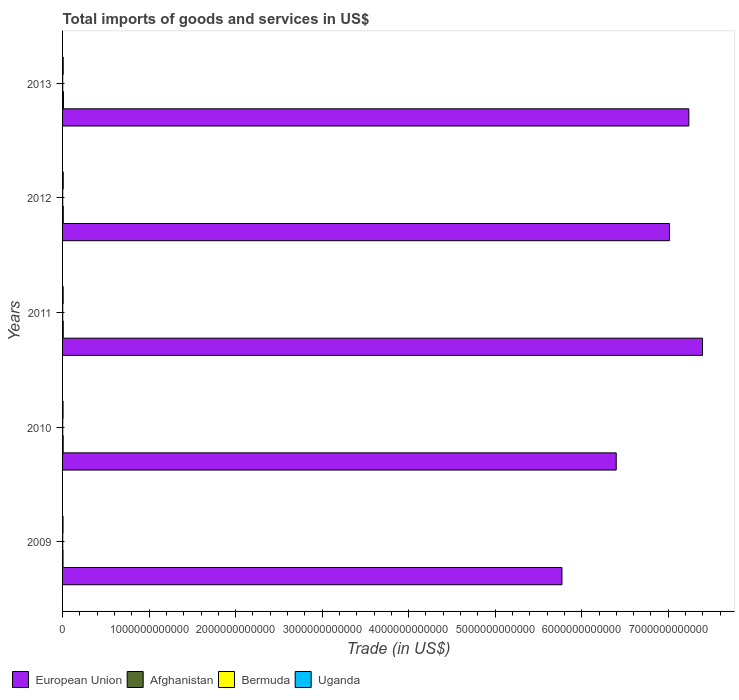How many different coloured bars are there?
Your answer should be very brief. 4. How many groups of bars are there?
Your answer should be very brief. 5. Are the number of bars per tick equal to the number of legend labels?
Offer a very short reply. Yes. Are the number of bars on each tick of the Y-axis equal?
Offer a terse response. Yes. How many bars are there on the 4th tick from the bottom?
Provide a succinct answer. 4. What is the label of the 3rd group of bars from the top?
Provide a short and direct response. 2011. In how many cases, is the number of bars for a given year not equal to the number of legend labels?
Give a very brief answer. 0. What is the total imports of goods and services in European Union in 2010?
Keep it short and to the point. 6.40e+12. Across all years, what is the maximum total imports of goods and services in European Union?
Your answer should be compact. 7.40e+12. Across all years, what is the minimum total imports of goods and services in Uganda?
Provide a succinct answer. 5.34e+09. In which year was the total imports of goods and services in Afghanistan minimum?
Keep it short and to the point. 2009. What is the total total imports of goods and services in Uganda in the graph?
Your answer should be compact. 3.31e+1. What is the difference between the total imports of goods and services in European Union in 2009 and that in 2013?
Your answer should be very brief. -1.47e+12. What is the difference between the total imports of goods and services in Bermuda in 2009 and the total imports of goods and services in Uganda in 2012?
Make the answer very short. -5.89e+09. What is the average total imports of goods and services in Uganda per year?
Offer a terse response. 6.63e+09. In the year 2012, what is the difference between the total imports of goods and services in Bermuda and total imports of goods and services in Uganda?
Keep it short and to the point. -6.07e+09. What is the ratio of the total imports of goods and services in Uganda in 2010 to that in 2011?
Provide a succinct answer. 0.84. Is the total imports of goods and services in European Union in 2010 less than that in 2012?
Provide a succinct answer. Yes. Is the difference between the total imports of goods and services in Bermuda in 2009 and 2011 greater than the difference between the total imports of goods and services in Uganda in 2009 and 2011?
Ensure brevity in your answer.  Yes. What is the difference between the highest and the second highest total imports of goods and services in Bermuda?
Give a very brief answer. 3.76e+07. What is the difference between the highest and the lowest total imports of goods and services in Uganda?
Your answer should be compact. 2.32e+09. In how many years, is the total imports of goods and services in Afghanistan greater than the average total imports of goods and services in Afghanistan taken over all years?
Provide a short and direct response. 3. What does the 1st bar from the top in 2010 represents?
Ensure brevity in your answer.  Uganda. What does the 2nd bar from the bottom in 2011 represents?
Offer a terse response. Afghanistan. Is it the case that in every year, the sum of the total imports of goods and services in Afghanistan and total imports of goods and services in European Union is greater than the total imports of goods and services in Bermuda?
Provide a short and direct response. Yes. How many years are there in the graph?
Provide a succinct answer. 5. What is the difference between two consecutive major ticks on the X-axis?
Provide a short and direct response. 1.00e+12. Are the values on the major ticks of X-axis written in scientific E-notation?
Keep it short and to the point. No. Does the graph contain any zero values?
Provide a short and direct response. No. Does the graph contain grids?
Your response must be concise. No. Where does the legend appear in the graph?
Your answer should be compact. Bottom left. How are the legend labels stacked?
Your response must be concise. Horizontal. What is the title of the graph?
Offer a very short reply. Total imports of goods and services in US$. What is the label or title of the X-axis?
Offer a very short reply. Trade (in US$). What is the label or title of the Y-axis?
Your response must be concise. Years. What is the Trade (in US$) in European Union in 2009?
Your response must be concise. 5.77e+12. What is the Trade (in US$) of Afghanistan in 2009?
Offer a terse response. 5.27e+09. What is the Trade (in US$) of Bermuda in 2009?
Your answer should be compact. 1.77e+09. What is the Trade (in US$) in Uganda in 2009?
Give a very brief answer. 5.34e+09. What is the Trade (in US$) in European Union in 2010?
Ensure brevity in your answer.  6.40e+12. What is the Trade (in US$) in Afghanistan in 2010?
Your response must be concise. 7.16e+09. What is the Trade (in US$) in Bermuda in 2010?
Your answer should be compact. 1.73e+09. What is the Trade (in US$) in Uganda in 2010?
Offer a terse response. 5.77e+09. What is the Trade (in US$) of European Union in 2011?
Keep it short and to the point. 7.40e+12. What is the Trade (in US$) of Afghanistan in 2011?
Keep it short and to the point. 7.92e+09. What is the Trade (in US$) of Bermuda in 2011?
Your response must be concise. 1.60e+09. What is the Trade (in US$) of Uganda in 2011?
Offer a terse response. 6.84e+09. What is the Trade (in US$) of European Union in 2012?
Keep it short and to the point. 7.01e+12. What is the Trade (in US$) of Afghanistan in 2012?
Provide a short and direct response. 8.04e+09. What is the Trade (in US$) of Bermuda in 2012?
Ensure brevity in your answer.  1.59e+09. What is the Trade (in US$) in Uganda in 2012?
Offer a very short reply. 7.66e+09. What is the Trade (in US$) in European Union in 2013?
Provide a succinct answer. 7.24e+12. What is the Trade (in US$) of Afghanistan in 2013?
Your response must be concise. 1.02e+1. What is the Trade (in US$) of Bermuda in 2013?
Your answer should be compact. 1.65e+09. What is the Trade (in US$) in Uganda in 2013?
Give a very brief answer. 7.53e+09. Across all years, what is the maximum Trade (in US$) in European Union?
Your response must be concise. 7.40e+12. Across all years, what is the maximum Trade (in US$) in Afghanistan?
Give a very brief answer. 1.02e+1. Across all years, what is the maximum Trade (in US$) in Bermuda?
Make the answer very short. 1.77e+09. Across all years, what is the maximum Trade (in US$) in Uganda?
Keep it short and to the point. 7.66e+09. Across all years, what is the minimum Trade (in US$) of European Union?
Offer a very short reply. 5.77e+12. Across all years, what is the minimum Trade (in US$) of Afghanistan?
Keep it short and to the point. 5.27e+09. Across all years, what is the minimum Trade (in US$) in Bermuda?
Give a very brief answer. 1.59e+09. Across all years, what is the minimum Trade (in US$) in Uganda?
Provide a short and direct response. 5.34e+09. What is the total Trade (in US$) of European Union in the graph?
Your response must be concise. 3.38e+13. What is the total Trade (in US$) in Afghanistan in the graph?
Ensure brevity in your answer.  3.86e+1. What is the total Trade (in US$) in Bermuda in the graph?
Your answer should be compact. 8.34e+09. What is the total Trade (in US$) of Uganda in the graph?
Offer a terse response. 3.31e+1. What is the difference between the Trade (in US$) of European Union in 2009 and that in 2010?
Provide a succinct answer. -6.27e+11. What is the difference between the Trade (in US$) of Afghanistan in 2009 and that in 2010?
Your answer should be very brief. -1.89e+09. What is the difference between the Trade (in US$) in Bermuda in 2009 and that in 2010?
Your answer should be compact. 3.76e+07. What is the difference between the Trade (in US$) of Uganda in 2009 and that in 2010?
Make the answer very short. -4.27e+08. What is the difference between the Trade (in US$) in European Union in 2009 and that in 2011?
Keep it short and to the point. -1.62e+12. What is the difference between the Trade (in US$) of Afghanistan in 2009 and that in 2011?
Provide a short and direct response. -2.65e+09. What is the difference between the Trade (in US$) in Bermuda in 2009 and that in 2011?
Offer a very short reply. 1.71e+08. What is the difference between the Trade (in US$) of Uganda in 2009 and that in 2011?
Make the answer very short. -1.50e+09. What is the difference between the Trade (in US$) of European Union in 2009 and that in 2012?
Make the answer very short. -1.24e+12. What is the difference between the Trade (in US$) in Afghanistan in 2009 and that in 2012?
Offer a very short reply. -2.77e+09. What is the difference between the Trade (in US$) of Bermuda in 2009 and that in 2012?
Give a very brief answer. 1.85e+08. What is the difference between the Trade (in US$) of Uganda in 2009 and that in 2012?
Keep it short and to the point. -2.32e+09. What is the difference between the Trade (in US$) in European Union in 2009 and that in 2013?
Your response must be concise. -1.47e+12. What is the difference between the Trade (in US$) in Afghanistan in 2009 and that in 2013?
Keep it short and to the point. -4.91e+09. What is the difference between the Trade (in US$) in Bermuda in 2009 and that in 2013?
Your response must be concise. 1.22e+08. What is the difference between the Trade (in US$) of Uganda in 2009 and that in 2013?
Your answer should be compact. -2.18e+09. What is the difference between the Trade (in US$) in European Union in 2010 and that in 2011?
Keep it short and to the point. -9.97e+11. What is the difference between the Trade (in US$) in Afghanistan in 2010 and that in 2011?
Your answer should be compact. -7.62e+08. What is the difference between the Trade (in US$) in Bermuda in 2010 and that in 2011?
Your answer should be very brief. 1.33e+08. What is the difference between the Trade (in US$) of Uganda in 2010 and that in 2011?
Offer a terse response. -1.07e+09. What is the difference between the Trade (in US$) of European Union in 2010 and that in 2012?
Your answer should be compact. -6.15e+11. What is the difference between the Trade (in US$) in Afghanistan in 2010 and that in 2012?
Your answer should be compact. -8.76e+08. What is the difference between the Trade (in US$) in Bermuda in 2010 and that in 2012?
Offer a terse response. 1.47e+08. What is the difference between the Trade (in US$) in Uganda in 2010 and that in 2012?
Your answer should be very brief. -1.89e+09. What is the difference between the Trade (in US$) of European Union in 2010 and that in 2013?
Provide a succinct answer. -8.39e+11. What is the difference between the Trade (in US$) of Afghanistan in 2010 and that in 2013?
Make the answer very short. -3.02e+09. What is the difference between the Trade (in US$) in Bermuda in 2010 and that in 2013?
Keep it short and to the point. 8.46e+07. What is the difference between the Trade (in US$) in Uganda in 2010 and that in 2013?
Provide a succinct answer. -1.76e+09. What is the difference between the Trade (in US$) in European Union in 2011 and that in 2012?
Provide a short and direct response. 3.82e+11. What is the difference between the Trade (in US$) in Afghanistan in 2011 and that in 2012?
Provide a succinct answer. -1.14e+08. What is the difference between the Trade (in US$) in Bermuda in 2011 and that in 2012?
Offer a very short reply. 1.42e+07. What is the difference between the Trade (in US$) of Uganda in 2011 and that in 2012?
Your response must be concise. -8.18e+08. What is the difference between the Trade (in US$) of European Union in 2011 and that in 2013?
Keep it short and to the point. 1.58e+11. What is the difference between the Trade (in US$) in Afghanistan in 2011 and that in 2013?
Make the answer very short. -2.26e+09. What is the difference between the Trade (in US$) in Bermuda in 2011 and that in 2013?
Provide a short and direct response. -4.84e+07. What is the difference between the Trade (in US$) of Uganda in 2011 and that in 2013?
Your answer should be compact. -6.83e+08. What is the difference between the Trade (in US$) in European Union in 2012 and that in 2013?
Your response must be concise. -2.24e+11. What is the difference between the Trade (in US$) in Afghanistan in 2012 and that in 2013?
Ensure brevity in your answer.  -2.14e+09. What is the difference between the Trade (in US$) of Bermuda in 2012 and that in 2013?
Provide a short and direct response. -6.26e+07. What is the difference between the Trade (in US$) of Uganda in 2012 and that in 2013?
Keep it short and to the point. 1.35e+08. What is the difference between the Trade (in US$) in European Union in 2009 and the Trade (in US$) in Afghanistan in 2010?
Provide a succinct answer. 5.76e+12. What is the difference between the Trade (in US$) of European Union in 2009 and the Trade (in US$) of Bermuda in 2010?
Offer a very short reply. 5.77e+12. What is the difference between the Trade (in US$) of European Union in 2009 and the Trade (in US$) of Uganda in 2010?
Provide a short and direct response. 5.77e+12. What is the difference between the Trade (in US$) in Afghanistan in 2009 and the Trade (in US$) in Bermuda in 2010?
Provide a succinct answer. 3.54e+09. What is the difference between the Trade (in US$) in Afghanistan in 2009 and the Trade (in US$) in Uganda in 2010?
Give a very brief answer. -5.02e+08. What is the difference between the Trade (in US$) in Bermuda in 2009 and the Trade (in US$) in Uganda in 2010?
Offer a very short reply. -4.00e+09. What is the difference between the Trade (in US$) of European Union in 2009 and the Trade (in US$) of Afghanistan in 2011?
Make the answer very short. 5.76e+12. What is the difference between the Trade (in US$) of European Union in 2009 and the Trade (in US$) of Bermuda in 2011?
Provide a short and direct response. 5.77e+12. What is the difference between the Trade (in US$) of European Union in 2009 and the Trade (in US$) of Uganda in 2011?
Ensure brevity in your answer.  5.76e+12. What is the difference between the Trade (in US$) in Afghanistan in 2009 and the Trade (in US$) in Bermuda in 2011?
Your answer should be very brief. 3.67e+09. What is the difference between the Trade (in US$) in Afghanistan in 2009 and the Trade (in US$) in Uganda in 2011?
Your response must be concise. -1.57e+09. What is the difference between the Trade (in US$) in Bermuda in 2009 and the Trade (in US$) in Uganda in 2011?
Ensure brevity in your answer.  -5.07e+09. What is the difference between the Trade (in US$) in European Union in 2009 and the Trade (in US$) in Afghanistan in 2012?
Offer a terse response. 5.76e+12. What is the difference between the Trade (in US$) in European Union in 2009 and the Trade (in US$) in Bermuda in 2012?
Provide a short and direct response. 5.77e+12. What is the difference between the Trade (in US$) of European Union in 2009 and the Trade (in US$) of Uganda in 2012?
Keep it short and to the point. 5.76e+12. What is the difference between the Trade (in US$) in Afghanistan in 2009 and the Trade (in US$) in Bermuda in 2012?
Provide a short and direct response. 3.68e+09. What is the difference between the Trade (in US$) in Afghanistan in 2009 and the Trade (in US$) in Uganda in 2012?
Offer a very short reply. -2.39e+09. What is the difference between the Trade (in US$) of Bermuda in 2009 and the Trade (in US$) of Uganda in 2012?
Provide a short and direct response. -5.89e+09. What is the difference between the Trade (in US$) in European Union in 2009 and the Trade (in US$) in Afghanistan in 2013?
Your answer should be compact. 5.76e+12. What is the difference between the Trade (in US$) in European Union in 2009 and the Trade (in US$) in Bermuda in 2013?
Your answer should be compact. 5.77e+12. What is the difference between the Trade (in US$) of European Union in 2009 and the Trade (in US$) of Uganda in 2013?
Provide a short and direct response. 5.76e+12. What is the difference between the Trade (in US$) of Afghanistan in 2009 and the Trade (in US$) of Bermuda in 2013?
Give a very brief answer. 3.62e+09. What is the difference between the Trade (in US$) in Afghanistan in 2009 and the Trade (in US$) in Uganda in 2013?
Keep it short and to the point. -2.26e+09. What is the difference between the Trade (in US$) of Bermuda in 2009 and the Trade (in US$) of Uganda in 2013?
Your answer should be compact. -5.76e+09. What is the difference between the Trade (in US$) of European Union in 2010 and the Trade (in US$) of Afghanistan in 2011?
Keep it short and to the point. 6.39e+12. What is the difference between the Trade (in US$) in European Union in 2010 and the Trade (in US$) in Bermuda in 2011?
Provide a succinct answer. 6.40e+12. What is the difference between the Trade (in US$) in European Union in 2010 and the Trade (in US$) in Uganda in 2011?
Keep it short and to the point. 6.39e+12. What is the difference between the Trade (in US$) in Afghanistan in 2010 and the Trade (in US$) in Bermuda in 2011?
Your answer should be compact. 5.56e+09. What is the difference between the Trade (in US$) of Afghanistan in 2010 and the Trade (in US$) of Uganda in 2011?
Give a very brief answer. 3.19e+08. What is the difference between the Trade (in US$) in Bermuda in 2010 and the Trade (in US$) in Uganda in 2011?
Offer a terse response. -5.11e+09. What is the difference between the Trade (in US$) of European Union in 2010 and the Trade (in US$) of Afghanistan in 2012?
Keep it short and to the point. 6.39e+12. What is the difference between the Trade (in US$) of European Union in 2010 and the Trade (in US$) of Bermuda in 2012?
Make the answer very short. 6.40e+12. What is the difference between the Trade (in US$) of European Union in 2010 and the Trade (in US$) of Uganda in 2012?
Keep it short and to the point. 6.39e+12. What is the difference between the Trade (in US$) in Afghanistan in 2010 and the Trade (in US$) in Bermuda in 2012?
Ensure brevity in your answer.  5.58e+09. What is the difference between the Trade (in US$) in Afghanistan in 2010 and the Trade (in US$) in Uganda in 2012?
Offer a very short reply. -4.99e+08. What is the difference between the Trade (in US$) of Bermuda in 2010 and the Trade (in US$) of Uganda in 2012?
Keep it short and to the point. -5.93e+09. What is the difference between the Trade (in US$) of European Union in 2010 and the Trade (in US$) of Afghanistan in 2013?
Offer a very short reply. 6.39e+12. What is the difference between the Trade (in US$) of European Union in 2010 and the Trade (in US$) of Bermuda in 2013?
Your answer should be very brief. 6.40e+12. What is the difference between the Trade (in US$) in European Union in 2010 and the Trade (in US$) in Uganda in 2013?
Offer a terse response. 6.39e+12. What is the difference between the Trade (in US$) of Afghanistan in 2010 and the Trade (in US$) of Bermuda in 2013?
Make the answer very short. 5.51e+09. What is the difference between the Trade (in US$) of Afghanistan in 2010 and the Trade (in US$) of Uganda in 2013?
Your response must be concise. -3.65e+08. What is the difference between the Trade (in US$) in Bermuda in 2010 and the Trade (in US$) in Uganda in 2013?
Your answer should be very brief. -5.79e+09. What is the difference between the Trade (in US$) in European Union in 2011 and the Trade (in US$) in Afghanistan in 2012?
Give a very brief answer. 7.39e+12. What is the difference between the Trade (in US$) of European Union in 2011 and the Trade (in US$) of Bermuda in 2012?
Your answer should be very brief. 7.39e+12. What is the difference between the Trade (in US$) in European Union in 2011 and the Trade (in US$) in Uganda in 2012?
Ensure brevity in your answer.  7.39e+12. What is the difference between the Trade (in US$) in Afghanistan in 2011 and the Trade (in US$) in Bermuda in 2012?
Give a very brief answer. 6.34e+09. What is the difference between the Trade (in US$) in Afghanistan in 2011 and the Trade (in US$) in Uganda in 2012?
Provide a short and direct response. 2.62e+08. What is the difference between the Trade (in US$) of Bermuda in 2011 and the Trade (in US$) of Uganda in 2012?
Your answer should be compact. -6.06e+09. What is the difference between the Trade (in US$) in European Union in 2011 and the Trade (in US$) in Afghanistan in 2013?
Offer a very short reply. 7.39e+12. What is the difference between the Trade (in US$) in European Union in 2011 and the Trade (in US$) in Bermuda in 2013?
Make the answer very short. 7.39e+12. What is the difference between the Trade (in US$) of European Union in 2011 and the Trade (in US$) of Uganda in 2013?
Ensure brevity in your answer.  7.39e+12. What is the difference between the Trade (in US$) of Afghanistan in 2011 and the Trade (in US$) of Bermuda in 2013?
Provide a succinct answer. 6.27e+09. What is the difference between the Trade (in US$) in Afghanistan in 2011 and the Trade (in US$) in Uganda in 2013?
Provide a short and direct response. 3.97e+08. What is the difference between the Trade (in US$) in Bermuda in 2011 and the Trade (in US$) in Uganda in 2013?
Ensure brevity in your answer.  -5.93e+09. What is the difference between the Trade (in US$) in European Union in 2012 and the Trade (in US$) in Afghanistan in 2013?
Your answer should be very brief. 7.00e+12. What is the difference between the Trade (in US$) in European Union in 2012 and the Trade (in US$) in Bermuda in 2013?
Your answer should be very brief. 7.01e+12. What is the difference between the Trade (in US$) of European Union in 2012 and the Trade (in US$) of Uganda in 2013?
Provide a short and direct response. 7.01e+12. What is the difference between the Trade (in US$) in Afghanistan in 2012 and the Trade (in US$) in Bermuda in 2013?
Your response must be concise. 6.39e+09. What is the difference between the Trade (in US$) of Afghanistan in 2012 and the Trade (in US$) of Uganda in 2013?
Your answer should be compact. 5.11e+08. What is the difference between the Trade (in US$) of Bermuda in 2012 and the Trade (in US$) of Uganda in 2013?
Your answer should be very brief. -5.94e+09. What is the average Trade (in US$) of European Union per year?
Your response must be concise. 6.76e+12. What is the average Trade (in US$) of Afghanistan per year?
Make the answer very short. 7.71e+09. What is the average Trade (in US$) of Bermuda per year?
Provide a succinct answer. 1.67e+09. What is the average Trade (in US$) of Uganda per year?
Offer a very short reply. 6.63e+09. In the year 2009, what is the difference between the Trade (in US$) of European Union and Trade (in US$) of Afghanistan?
Keep it short and to the point. 5.77e+12. In the year 2009, what is the difference between the Trade (in US$) of European Union and Trade (in US$) of Bermuda?
Your answer should be very brief. 5.77e+12. In the year 2009, what is the difference between the Trade (in US$) of European Union and Trade (in US$) of Uganda?
Offer a terse response. 5.77e+12. In the year 2009, what is the difference between the Trade (in US$) in Afghanistan and Trade (in US$) in Bermuda?
Ensure brevity in your answer.  3.50e+09. In the year 2009, what is the difference between the Trade (in US$) in Afghanistan and Trade (in US$) in Uganda?
Your answer should be very brief. -7.40e+07. In the year 2009, what is the difference between the Trade (in US$) in Bermuda and Trade (in US$) in Uganda?
Your answer should be very brief. -3.57e+09. In the year 2010, what is the difference between the Trade (in US$) in European Union and Trade (in US$) in Afghanistan?
Provide a short and direct response. 6.39e+12. In the year 2010, what is the difference between the Trade (in US$) of European Union and Trade (in US$) of Bermuda?
Your answer should be compact. 6.40e+12. In the year 2010, what is the difference between the Trade (in US$) of European Union and Trade (in US$) of Uganda?
Offer a terse response. 6.39e+12. In the year 2010, what is the difference between the Trade (in US$) in Afghanistan and Trade (in US$) in Bermuda?
Ensure brevity in your answer.  5.43e+09. In the year 2010, what is the difference between the Trade (in US$) of Afghanistan and Trade (in US$) of Uganda?
Offer a very short reply. 1.39e+09. In the year 2010, what is the difference between the Trade (in US$) of Bermuda and Trade (in US$) of Uganda?
Provide a short and direct response. -4.04e+09. In the year 2011, what is the difference between the Trade (in US$) in European Union and Trade (in US$) in Afghanistan?
Your response must be concise. 7.39e+12. In the year 2011, what is the difference between the Trade (in US$) in European Union and Trade (in US$) in Bermuda?
Provide a short and direct response. 7.39e+12. In the year 2011, what is the difference between the Trade (in US$) of European Union and Trade (in US$) of Uganda?
Keep it short and to the point. 7.39e+12. In the year 2011, what is the difference between the Trade (in US$) of Afghanistan and Trade (in US$) of Bermuda?
Offer a terse response. 6.32e+09. In the year 2011, what is the difference between the Trade (in US$) of Afghanistan and Trade (in US$) of Uganda?
Keep it short and to the point. 1.08e+09. In the year 2011, what is the difference between the Trade (in US$) of Bermuda and Trade (in US$) of Uganda?
Your answer should be compact. -5.24e+09. In the year 2012, what is the difference between the Trade (in US$) in European Union and Trade (in US$) in Afghanistan?
Make the answer very short. 7.01e+12. In the year 2012, what is the difference between the Trade (in US$) in European Union and Trade (in US$) in Bermuda?
Provide a succinct answer. 7.01e+12. In the year 2012, what is the difference between the Trade (in US$) of European Union and Trade (in US$) of Uganda?
Give a very brief answer. 7.01e+12. In the year 2012, what is the difference between the Trade (in US$) in Afghanistan and Trade (in US$) in Bermuda?
Make the answer very short. 6.45e+09. In the year 2012, what is the difference between the Trade (in US$) of Afghanistan and Trade (in US$) of Uganda?
Make the answer very short. 3.77e+08. In the year 2012, what is the difference between the Trade (in US$) in Bermuda and Trade (in US$) in Uganda?
Your answer should be compact. -6.07e+09. In the year 2013, what is the difference between the Trade (in US$) in European Union and Trade (in US$) in Afghanistan?
Provide a succinct answer. 7.23e+12. In the year 2013, what is the difference between the Trade (in US$) in European Union and Trade (in US$) in Bermuda?
Provide a succinct answer. 7.24e+12. In the year 2013, what is the difference between the Trade (in US$) in European Union and Trade (in US$) in Uganda?
Offer a very short reply. 7.23e+12. In the year 2013, what is the difference between the Trade (in US$) in Afghanistan and Trade (in US$) in Bermuda?
Your answer should be very brief. 8.53e+09. In the year 2013, what is the difference between the Trade (in US$) in Afghanistan and Trade (in US$) in Uganda?
Provide a succinct answer. 2.65e+09. In the year 2013, what is the difference between the Trade (in US$) of Bermuda and Trade (in US$) of Uganda?
Make the answer very short. -5.88e+09. What is the ratio of the Trade (in US$) of European Union in 2009 to that in 2010?
Your answer should be compact. 0.9. What is the ratio of the Trade (in US$) in Afghanistan in 2009 to that in 2010?
Your answer should be very brief. 0.74. What is the ratio of the Trade (in US$) of Bermuda in 2009 to that in 2010?
Make the answer very short. 1.02. What is the ratio of the Trade (in US$) in Uganda in 2009 to that in 2010?
Provide a short and direct response. 0.93. What is the ratio of the Trade (in US$) of European Union in 2009 to that in 2011?
Make the answer very short. 0.78. What is the ratio of the Trade (in US$) of Afghanistan in 2009 to that in 2011?
Your response must be concise. 0.67. What is the ratio of the Trade (in US$) of Bermuda in 2009 to that in 2011?
Provide a succinct answer. 1.11. What is the ratio of the Trade (in US$) of Uganda in 2009 to that in 2011?
Ensure brevity in your answer.  0.78. What is the ratio of the Trade (in US$) of European Union in 2009 to that in 2012?
Your response must be concise. 0.82. What is the ratio of the Trade (in US$) of Afghanistan in 2009 to that in 2012?
Your answer should be compact. 0.66. What is the ratio of the Trade (in US$) of Bermuda in 2009 to that in 2012?
Make the answer very short. 1.12. What is the ratio of the Trade (in US$) of Uganda in 2009 to that in 2012?
Your response must be concise. 0.7. What is the ratio of the Trade (in US$) of European Union in 2009 to that in 2013?
Keep it short and to the point. 0.8. What is the ratio of the Trade (in US$) of Afghanistan in 2009 to that in 2013?
Offer a very short reply. 0.52. What is the ratio of the Trade (in US$) in Bermuda in 2009 to that in 2013?
Give a very brief answer. 1.07. What is the ratio of the Trade (in US$) in Uganda in 2009 to that in 2013?
Offer a terse response. 0.71. What is the ratio of the Trade (in US$) in European Union in 2010 to that in 2011?
Your answer should be compact. 0.87. What is the ratio of the Trade (in US$) of Afghanistan in 2010 to that in 2011?
Your answer should be very brief. 0.9. What is the ratio of the Trade (in US$) of Bermuda in 2010 to that in 2011?
Provide a short and direct response. 1.08. What is the ratio of the Trade (in US$) of Uganda in 2010 to that in 2011?
Your answer should be very brief. 0.84. What is the ratio of the Trade (in US$) of European Union in 2010 to that in 2012?
Make the answer very short. 0.91. What is the ratio of the Trade (in US$) in Afghanistan in 2010 to that in 2012?
Your response must be concise. 0.89. What is the ratio of the Trade (in US$) of Bermuda in 2010 to that in 2012?
Offer a terse response. 1.09. What is the ratio of the Trade (in US$) in Uganda in 2010 to that in 2012?
Keep it short and to the point. 0.75. What is the ratio of the Trade (in US$) in European Union in 2010 to that in 2013?
Keep it short and to the point. 0.88. What is the ratio of the Trade (in US$) of Afghanistan in 2010 to that in 2013?
Offer a very short reply. 0.7. What is the ratio of the Trade (in US$) in Bermuda in 2010 to that in 2013?
Your answer should be very brief. 1.05. What is the ratio of the Trade (in US$) in Uganda in 2010 to that in 2013?
Provide a succinct answer. 0.77. What is the ratio of the Trade (in US$) of European Union in 2011 to that in 2012?
Offer a terse response. 1.05. What is the ratio of the Trade (in US$) in Afghanistan in 2011 to that in 2012?
Your response must be concise. 0.99. What is the ratio of the Trade (in US$) of Bermuda in 2011 to that in 2012?
Make the answer very short. 1.01. What is the ratio of the Trade (in US$) in Uganda in 2011 to that in 2012?
Provide a short and direct response. 0.89. What is the ratio of the Trade (in US$) in European Union in 2011 to that in 2013?
Your response must be concise. 1.02. What is the ratio of the Trade (in US$) in Afghanistan in 2011 to that in 2013?
Offer a very short reply. 0.78. What is the ratio of the Trade (in US$) of Bermuda in 2011 to that in 2013?
Provide a succinct answer. 0.97. What is the ratio of the Trade (in US$) of Uganda in 2011 to that in 2013?
Your answer should be very brief. 0.91. What is the ratio of the Trade (in US$) in European Union in 2012 to that in 2013?
Offer a very short reply. 0.97. What is the ratio of the Trade (in US$) of Afghanistan in 2012 to that in 2013?
Make the answer very short. 0.79. What is the ratio of the Trade (in US$) of Bermuda in 2012 to that in 2013?
Provide a succinct answer. 0.96. What is the ratio of the Trade (in US$) in Uganda in 2012 to that in 2013?
Your answer should be very brief. 1.02. What is the difference between the highest and the second highest Trade (in US$) in European Union?
Your response must be concise. 1.58e+11. What is the difference between the highest and the second highest Trade (in US$) of Afghanistan?
Keep it short and to the point. 2.14e+09. What is the difference between the highest and the second highest Trade (in US$) in Bermuda?
Keep it short and to the point. 3.76e+07. What is the difference between the highest and the second highest Trade (in US$) of Uganda?
Provide a succinct answer. 1.35e+08. What is the difference between the highest and the lowest Trade (in US$) in European Union?
Your response must be concise. 1.62e+12. What is the difference between the highest and the lowest Trade (in US$) in Afghanistan?
Make the answer very short. 4.91e+09. What is the difference between the highest and the lowest Trade (in US$) in Bermuda?
Provide a short and direct response. 1.85e+08. What is the difference between the highest and the lowest Trade (in US$) of Uganda?
Make the answer very short. 2.32e+09. 